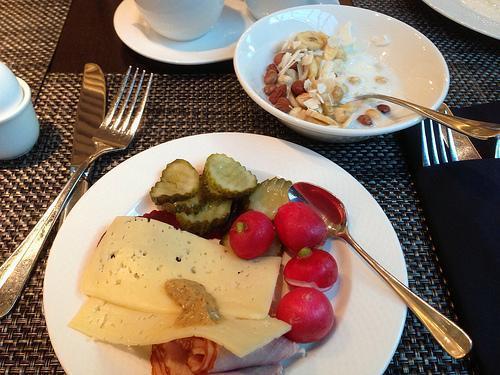How many forks?
Give a very brief answer. 2. 